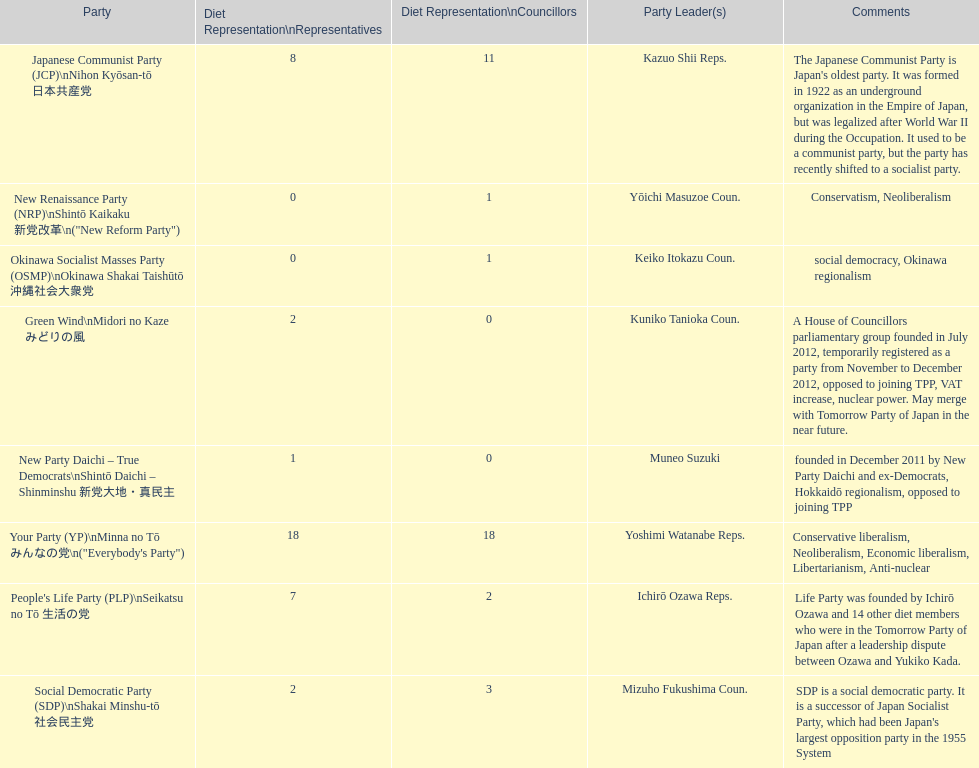What party is listed previous to the new renaissance party? New Party Daichi - True Democrats. 